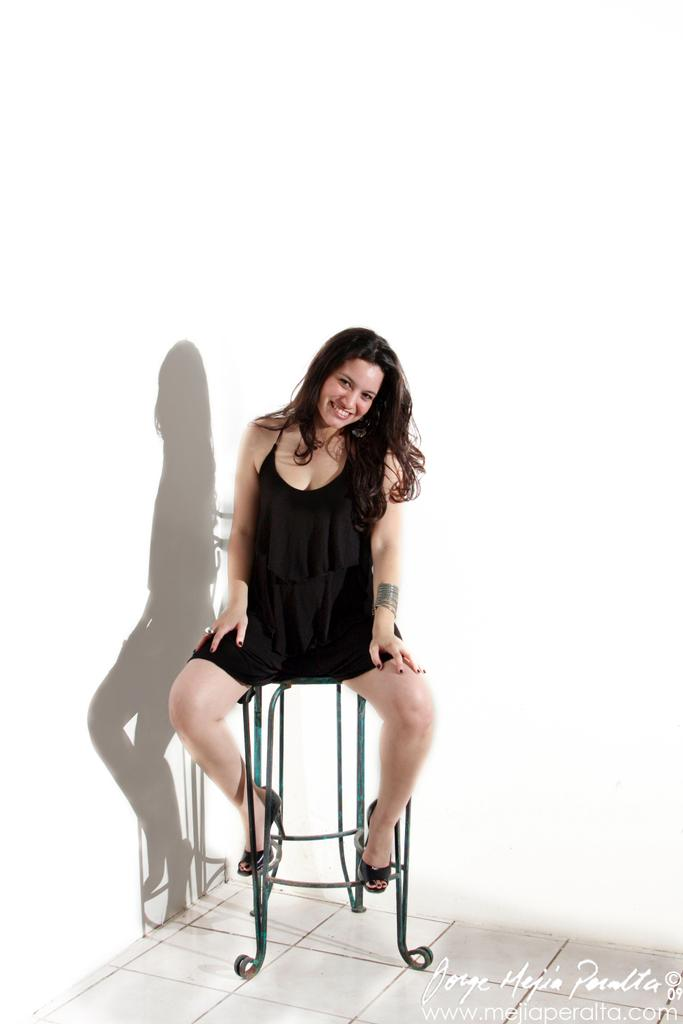Who or what is present in the image? There is a person in the image. What is the person wearing? The person is wearing a black dress. What is the person doing in the image? The person is sitting on a chair. Can you see any planes flying over the ocean in the image? There is no plane or ocean present in the image; it only features a person sitting on a chair wearing a black dress. 